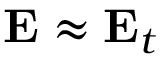Convert formula to latex. <formula><loc_0><loc_0><loc_500><loc_500>E \approx E _ { t }</formula> 